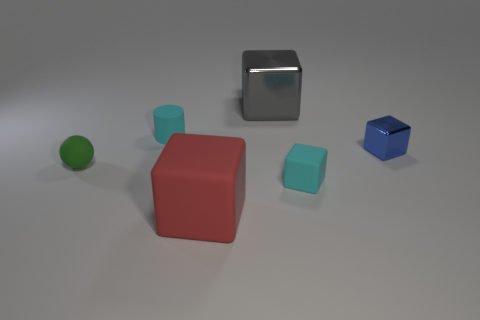Is the material of the cylinder the same as the block behind the tiny shiny object?
Make the answer very short. No. What material is the tiny cyan cube?
Keep it short and to the point. Rubber. What number of other objects are there of the same material as the gray cube?
Give a very brief answer. 1. What is the shape of the thing that is both to the left of the red matte block and on the right side of the small green sphere?
Give a very brief answer. Cylinder. There is another cube that is made of the same material as the gray block; what is its color?
Offer a very short reply. Blue. Is the number of small blue objects on the left side of the blue block the same as the number of large gray cylinders?
Make the answer very short. Yes. What is the shape of the blue metallic thing that is the same size as the green ball?
Keep it short and to the point. Cube. How many other objects are there of the same shape as the gray metallic object?
Provide a short and direct response. 3. Do the gray object and the rubber block that is to the right of the gray metallic cube have the same size?
Provide a succinct answer. No. What number of objects are either small matte things left of the big gray cube or green balls?
Offer a very short reply. 2. 